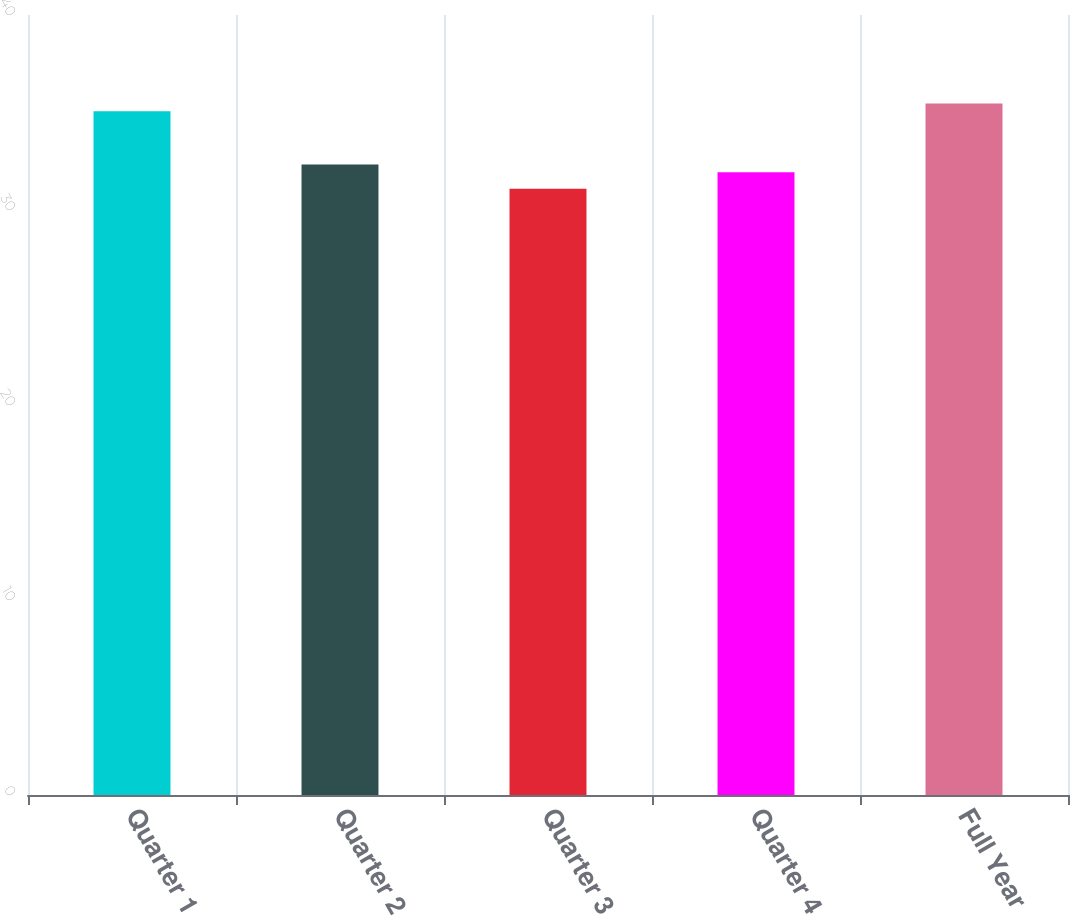<chart> <loc_0><loc_0><loc_500><loc_500><bar_chart><fcel>Quarter 1<fcel>Quarter 2<fcel>Quarter 3<fcel>Quarter 4<fcel>Full Year<nl><fcel>35.06<fcel>32.33<fcel>31.09<fcel>31.93<fcel>35.46<nl></chart> 